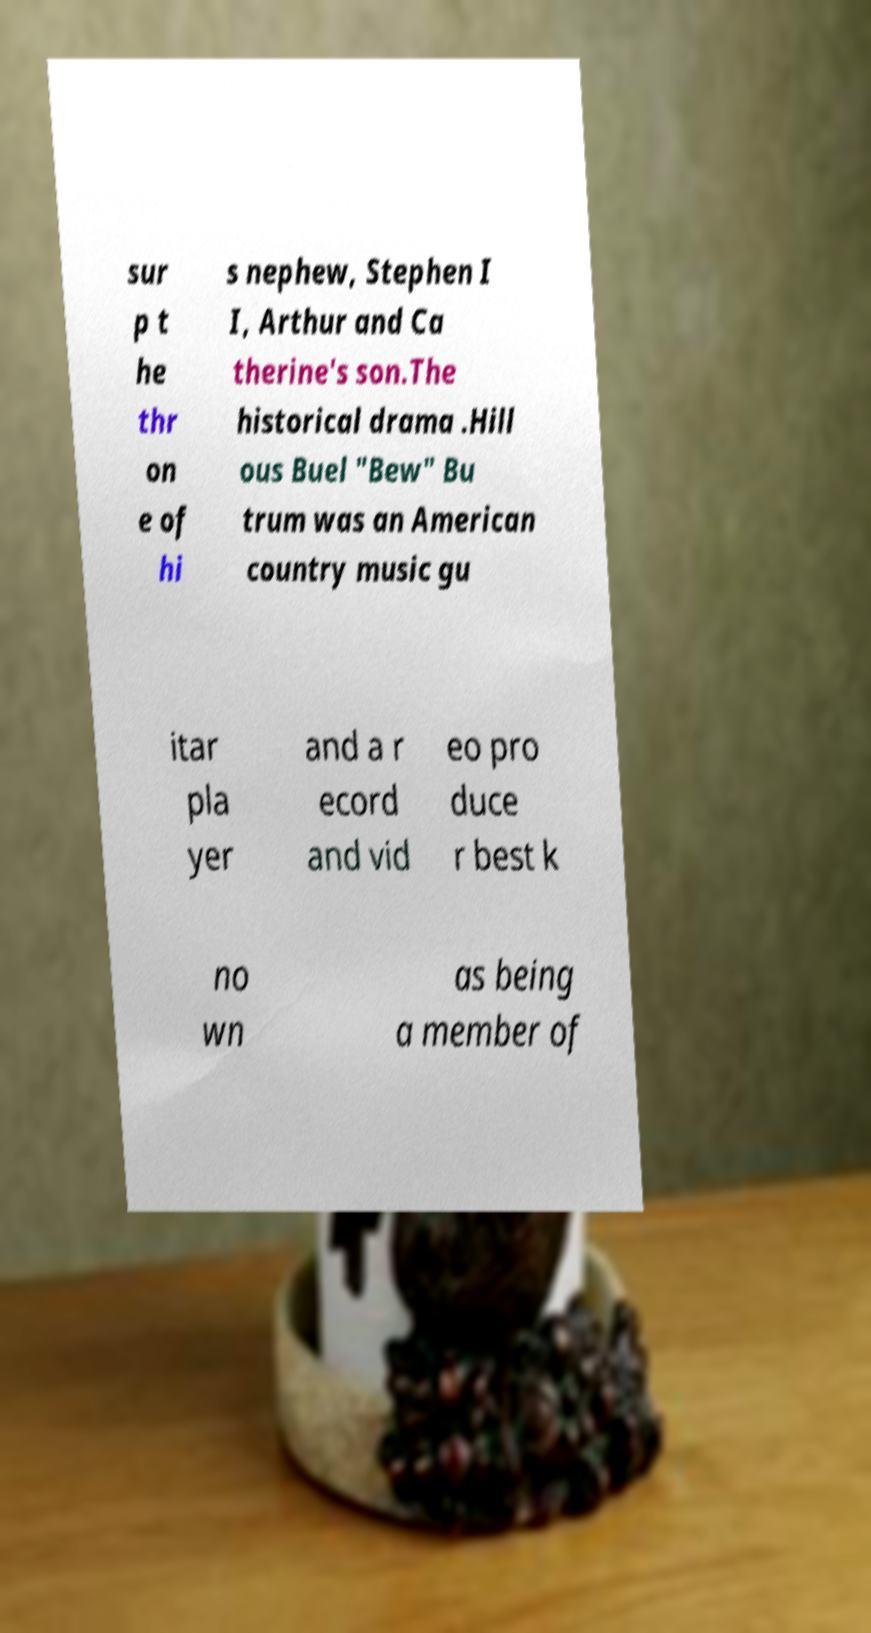There's text embedded in this image that I need extracted. Can you transcribe it verbatim? sur p t he thr on e of hi s nephew, Stephen I I, Arthur and Ca therine's son.The historical drama .Hill ous Buel "Bew" Bu trum was an American country music gu itar pla yer and a r ecord and vid eo pro duce r best k no wn as being a member of 